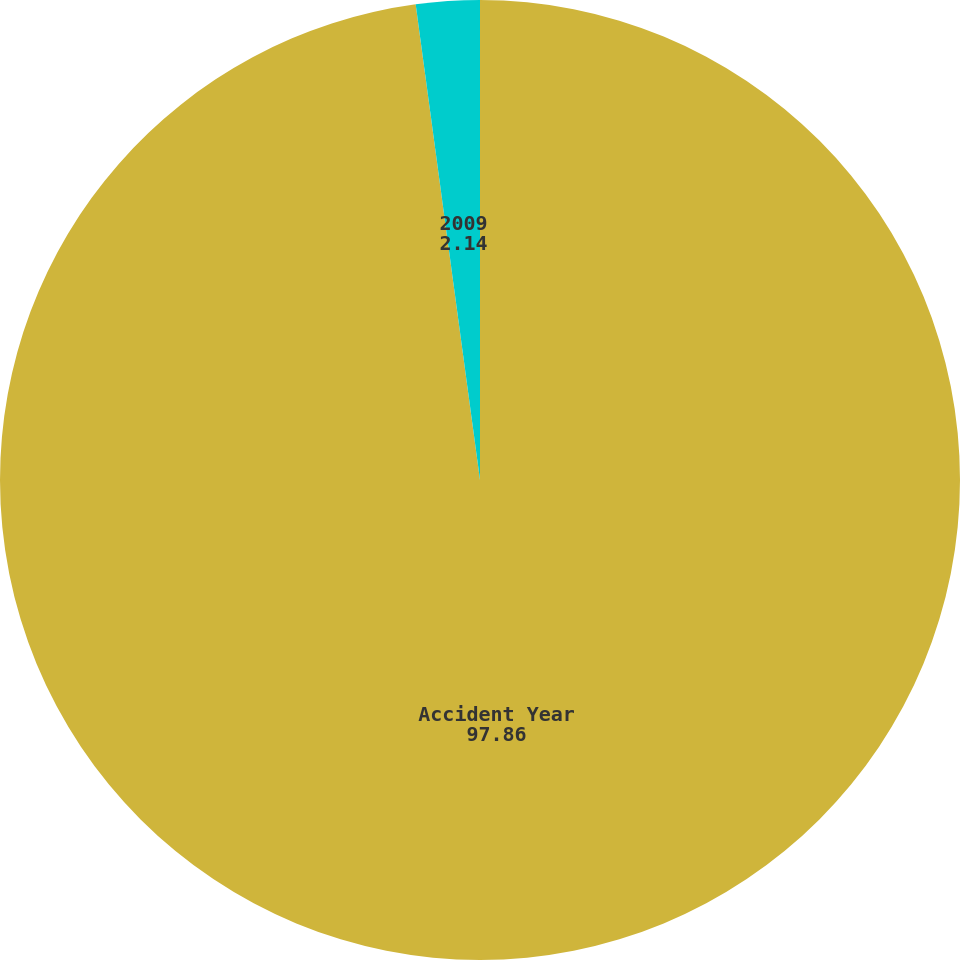<chart> <loc_0><loc_0><loc_500><loc_500><pie_chart><fcel>Accident Year<fcel>2009<nl><fcel>97.86%<fcel>2.14%<nl></chart> 